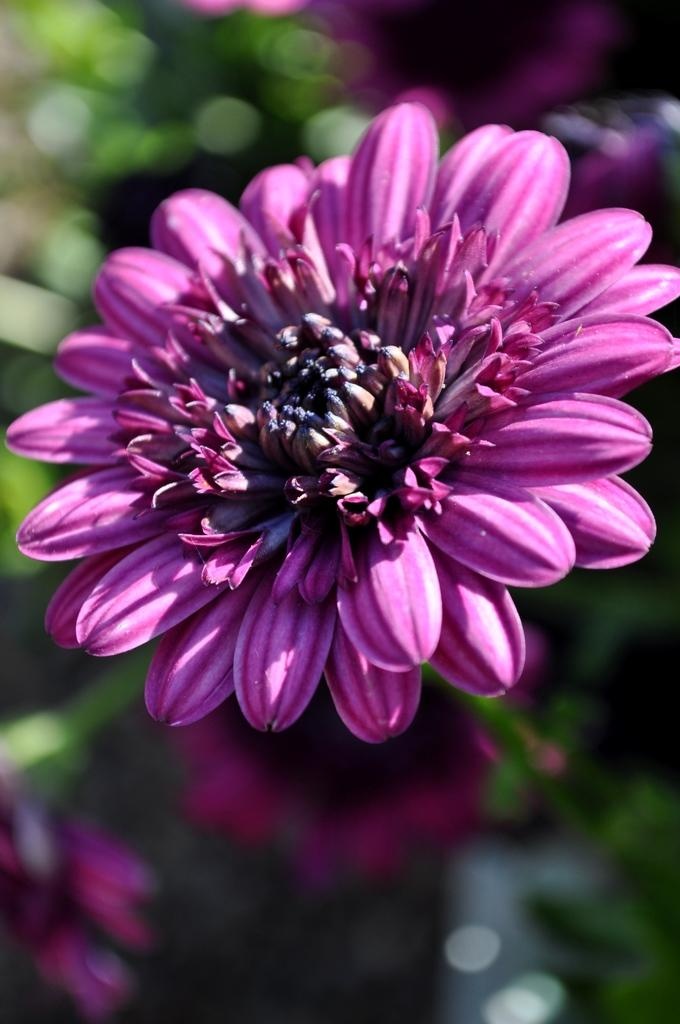What is the main subject of the image? There is a flower in the image. Can you describe the background of the image? The background has a blurred view. Are there any other flowers visible in the image? Yes, there are other flowers visible in the image. What color can be seen in the image? The color green is present in the image. What type of stew is being prepared in the image? There is no stew present in the image; it features a flower and other flowers with a blurred background. Can you see any branches in the image? There are no branches visible in the image; it focuses on flowers and their colors. 